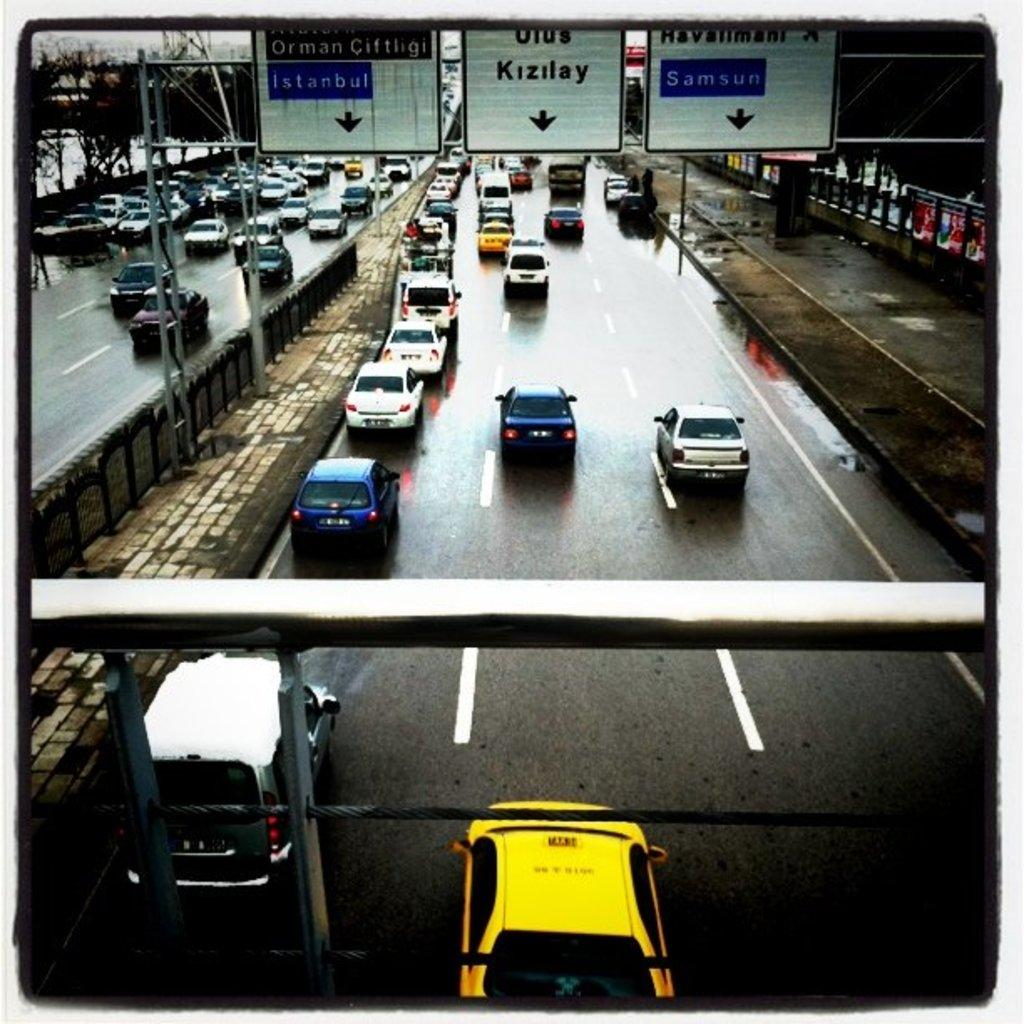<image>
Offer a succinct explanation of the picture presented. A busy freeway has white signs going across the traffic and the one to the right says Samsun. 